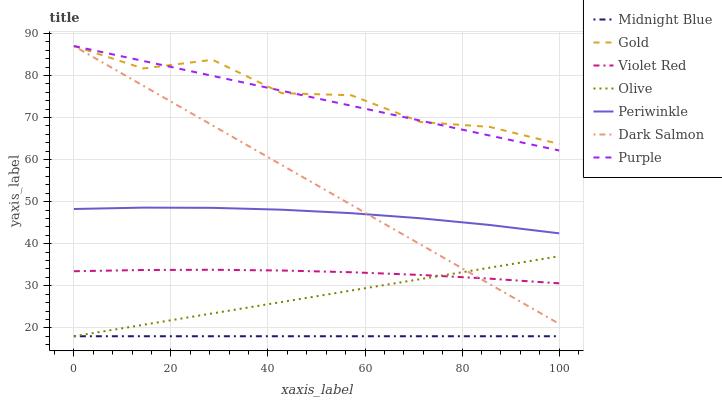Does Midnight Blue have the minimum area under the curve?
Answer yes or no. Yes. Does Gold have the maximum area under the curve?
Answer yes or no. Yes. Does Gold have the minimum area under the curve?
Answer yes or no. No. Does Midnight Blue have the maximum area under the curve?
Answer yes or no. No. Is Midnight Blue the smoothest?
Answer yes or no. Yes. Is Gold the roughest?
Answer yes or no. Yes. Is Gold the smoothest?
Answer yes or no. No. Is Midnight Blue the roughest?
Answer yes or no. No. Does Midnight Blue have the lowest value?
Answer yes or no. Yes. Does Gold have the lowest value?
Answer yes or no. No. Does Dark Salmon have the highest value?
Answer yes or no. Yes. Does Midnight Blue have the highest value?
Answer yes or no. No. Is Midnight Blue less than Gold?
Answer yes or no. Yes. Is Purple greater than Olive?
Answer yes or no. Yes. Does Periwinkle intersect Dark Salmon?
Answer yes or no. Yes. Is Periwinkle less than Dark Salmon?
Answer yes or no. No. Is Periwinkle greater than Dark Salmon?
Answer yes or no. No. Does Midnight Blue intersect Gold?
Answer yes or no. No. 